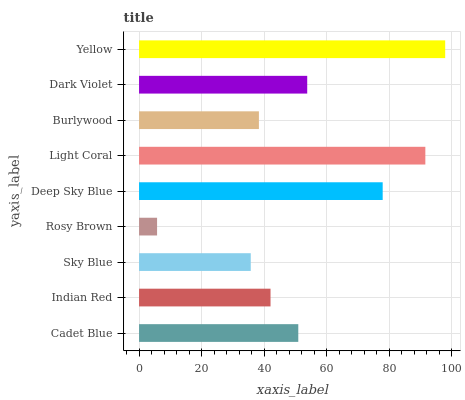Is Rosy Brown the minimum?
Answer yes or no. Yes. Is Yellow the maximum?
Answer yes or no. Yes. Is Indian Red the minimum?
Answer yes or no. No. Is Indian Red the maximum?
Answer yes or no. No. Is Cadet Blue greater than Indian Red?
Answer yes or no. Yes. Is Indian Red less than Cadet Blue?
Answer yes or no. Yes. Is Indian Red greater than Cadet Blue?
Answer yes or no. No. Is Cadet Blue less than Indian Red?
Answer yes or no. No. Is Cadet Blue the high median?
Answer yes or no. Yes. Is Cadet Blue the low median?
Answer yes or no. Yes. Is Sky Blue the high median?
Answer yes or no. No. Is Rosy Brown the low median?
Answer yes or no. No. 